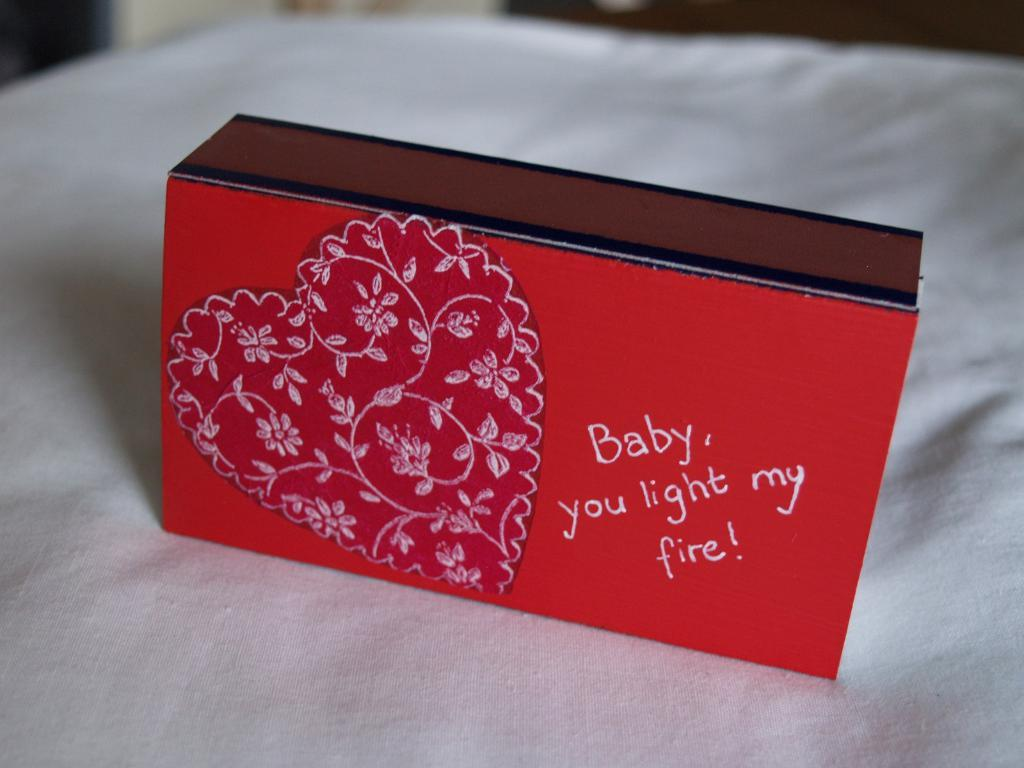<image>
Provide a brief description of the given image. a red box with a heart on it saying Baby you light my fire 